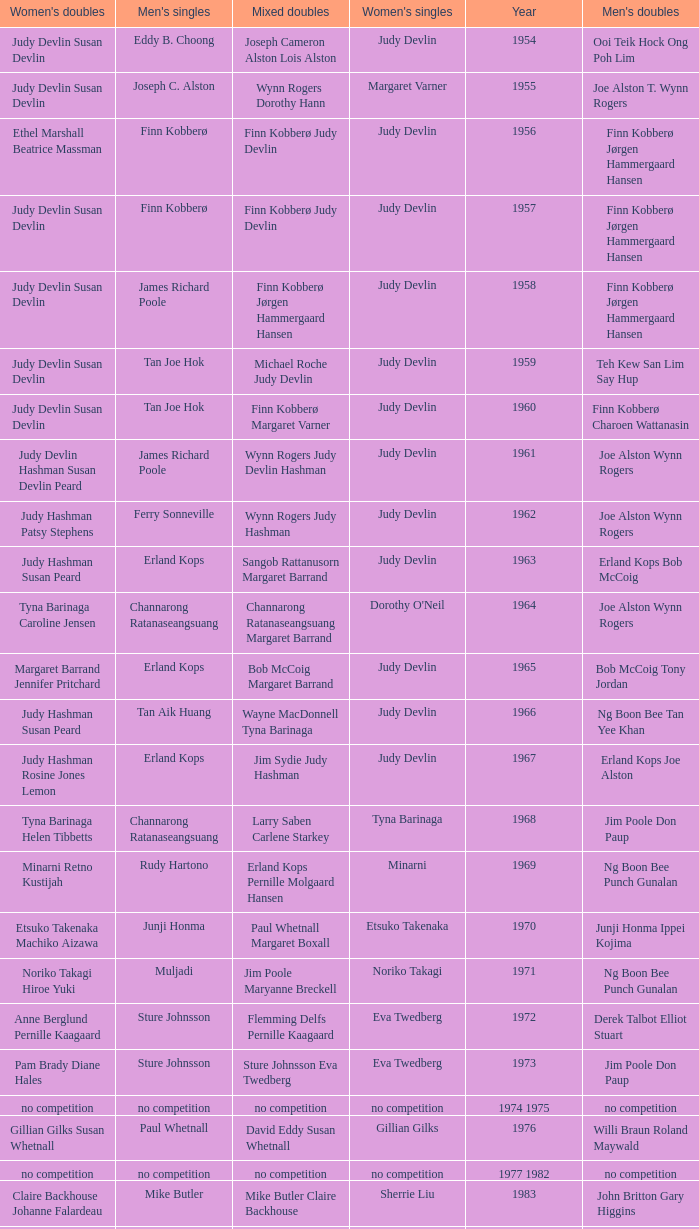Who was the women's singles champion in 1984? Luo Yun. 